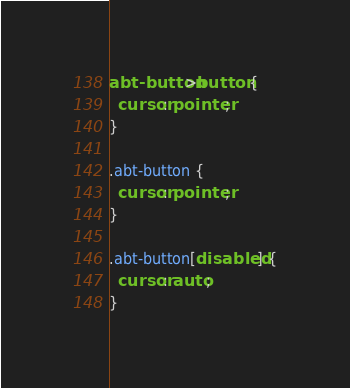Convert code to text. <code><loc_0><loc_0><loc_500><loc_500><_CSS_>abt-button>button {
  cursor: pointer;
}

.abt-button {
  cursor: pointer;
}

.abt-button[disabled] {
  cursor: auto;
}
</code> 